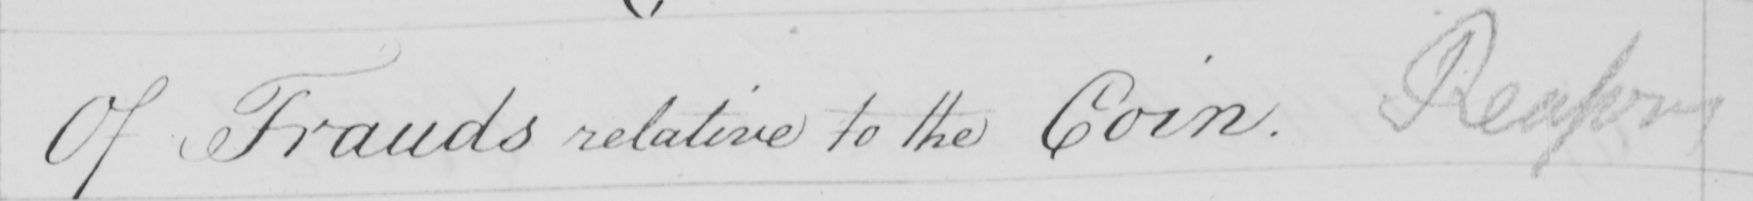Can you tell me what this handwritten text says? Of Frauds relative to the Coin . Reasons 